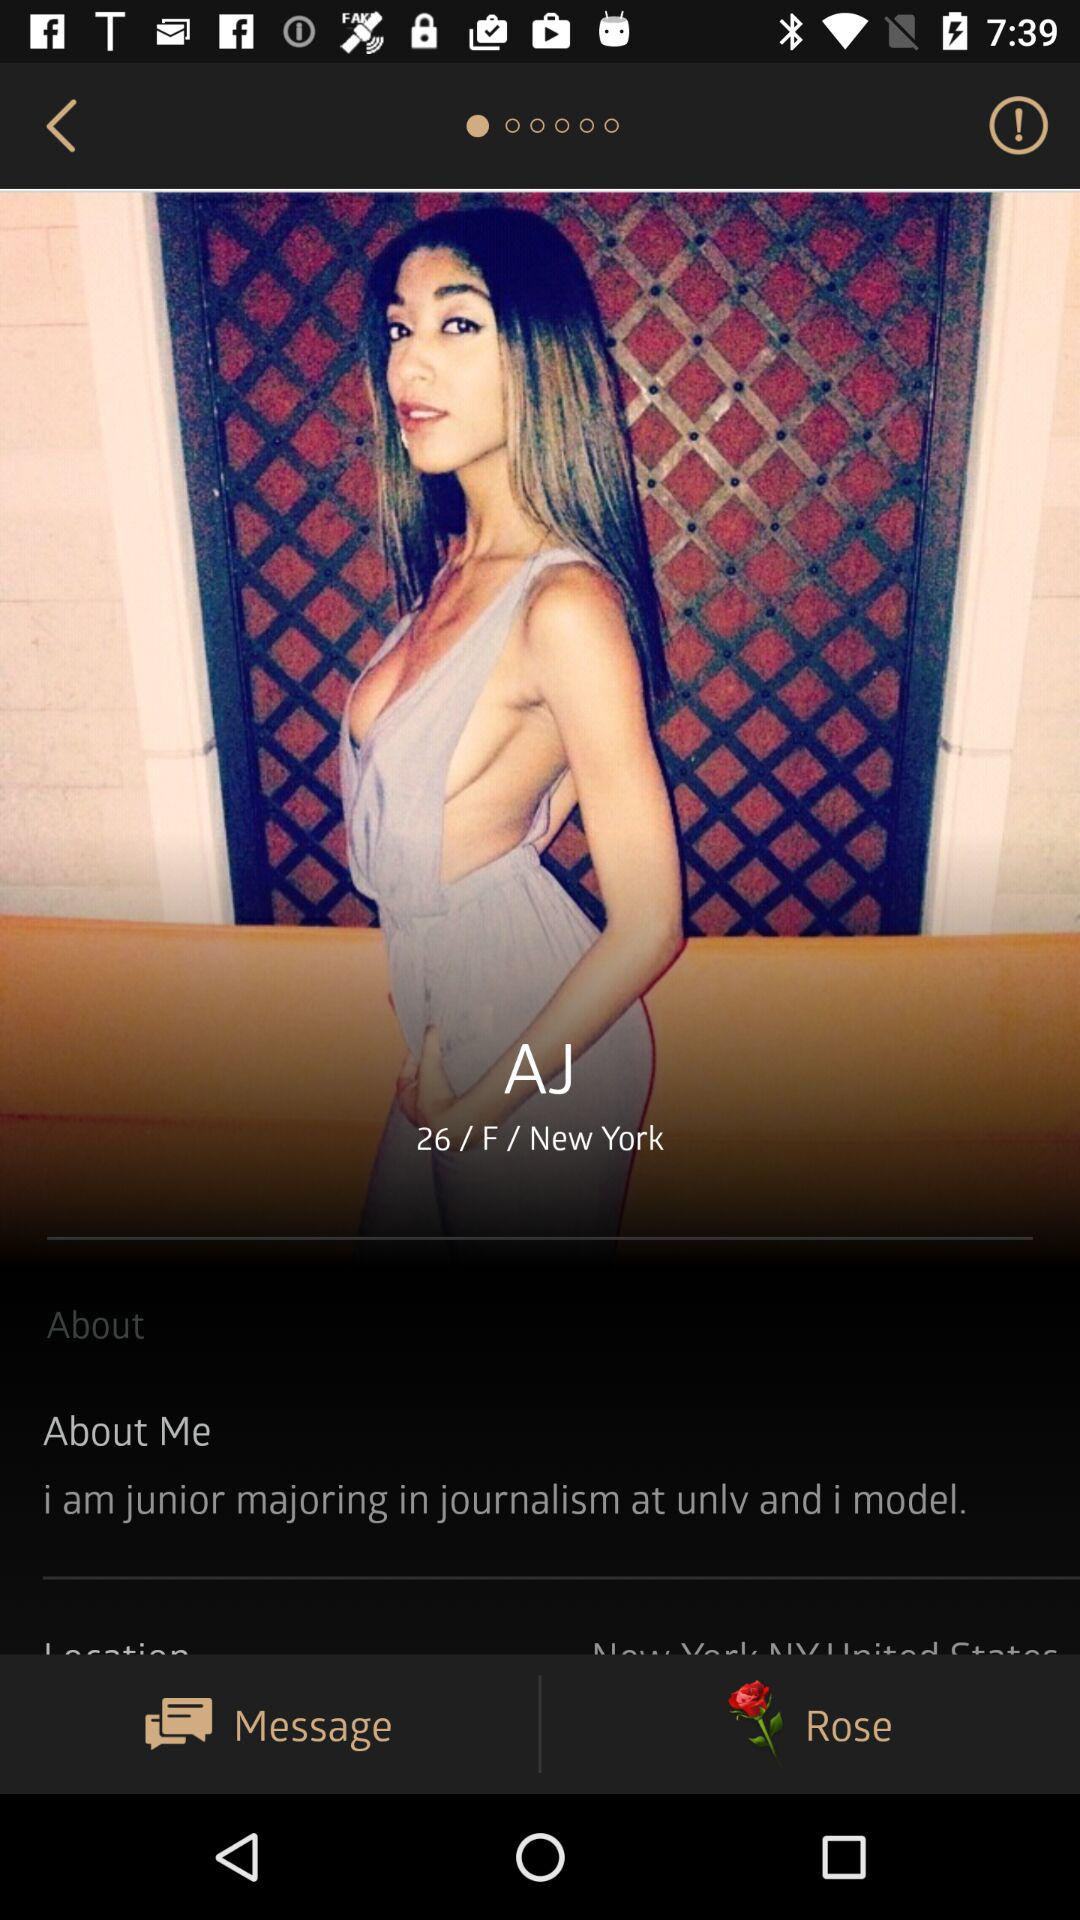What's the age of the user? The age of the user is 26. 